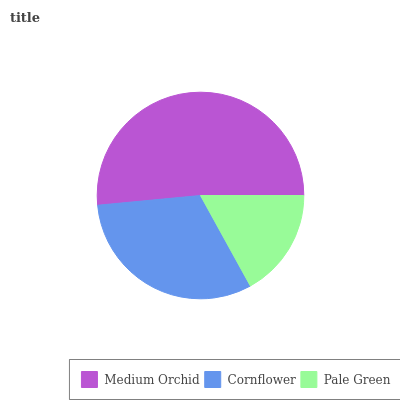Is Pale Green the minimum?
Answer yes or no. Yes. Is Medium Orchid the maximum?
Answer yes or no. Yes. Is Cornflower the minimum?
Answer yes or no. No. Is Cornflower the maximum?
Answer yes or no. No. Is Medium Orchid greater than Cornflower?
Answer yes or no. Yes. Is Cornflower less than Medium Orchid?
Answer yes or no. Yes. Is Cornflower greater than Medium Orchid?
Answer yes or no. No. Is Medium Orchid less than Cornflower?
Answer yes or no. No. Is Cornflower the high median?
Answer yes or no. Yes. Is Cornflower the low median?
Answer yes or no. Yes. Is Medium Orchid the high median?
Answer yes or no. No. Is Pale Green the low median?
Answer yes or no. No. 